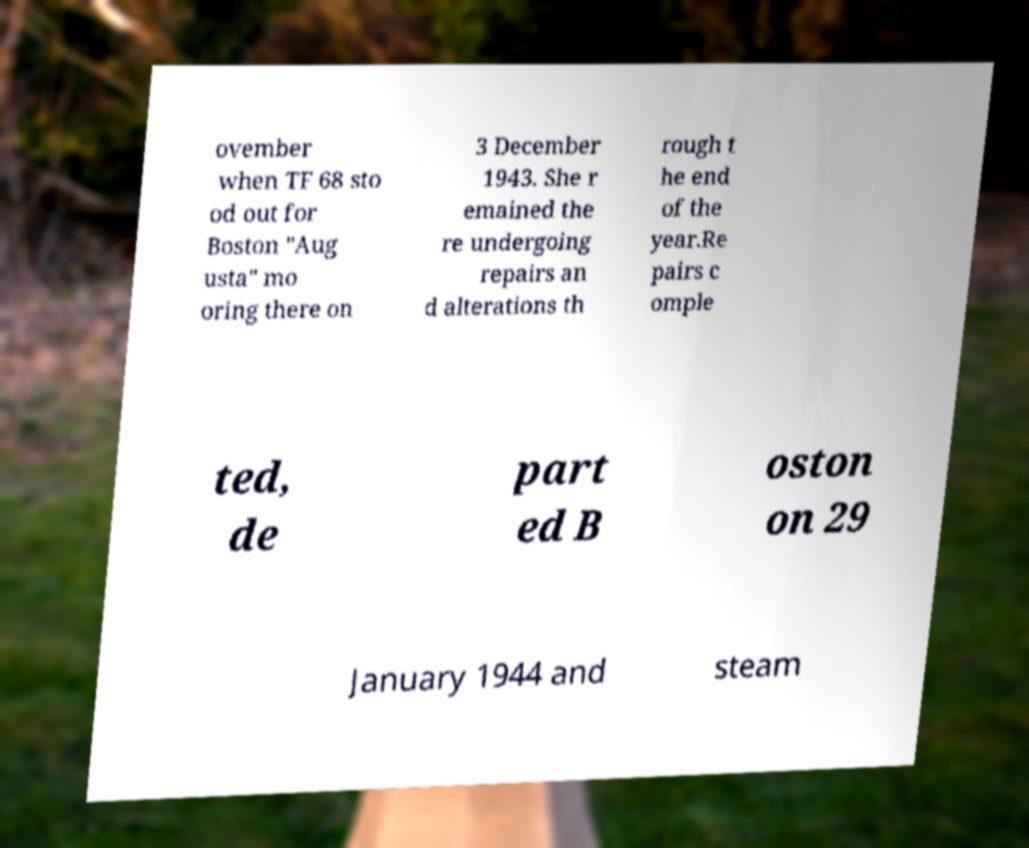Please identify and transcribe the text found in this image. ovember when TF 68 sto od out for Boston "Aug usta" mo oring there on 3 December 1943. She r emained the re undergoing repairs an d alterations th rough t he end of the year.Re pairs c omple ted, de part ed B oston on 29 January 1944 and steam 